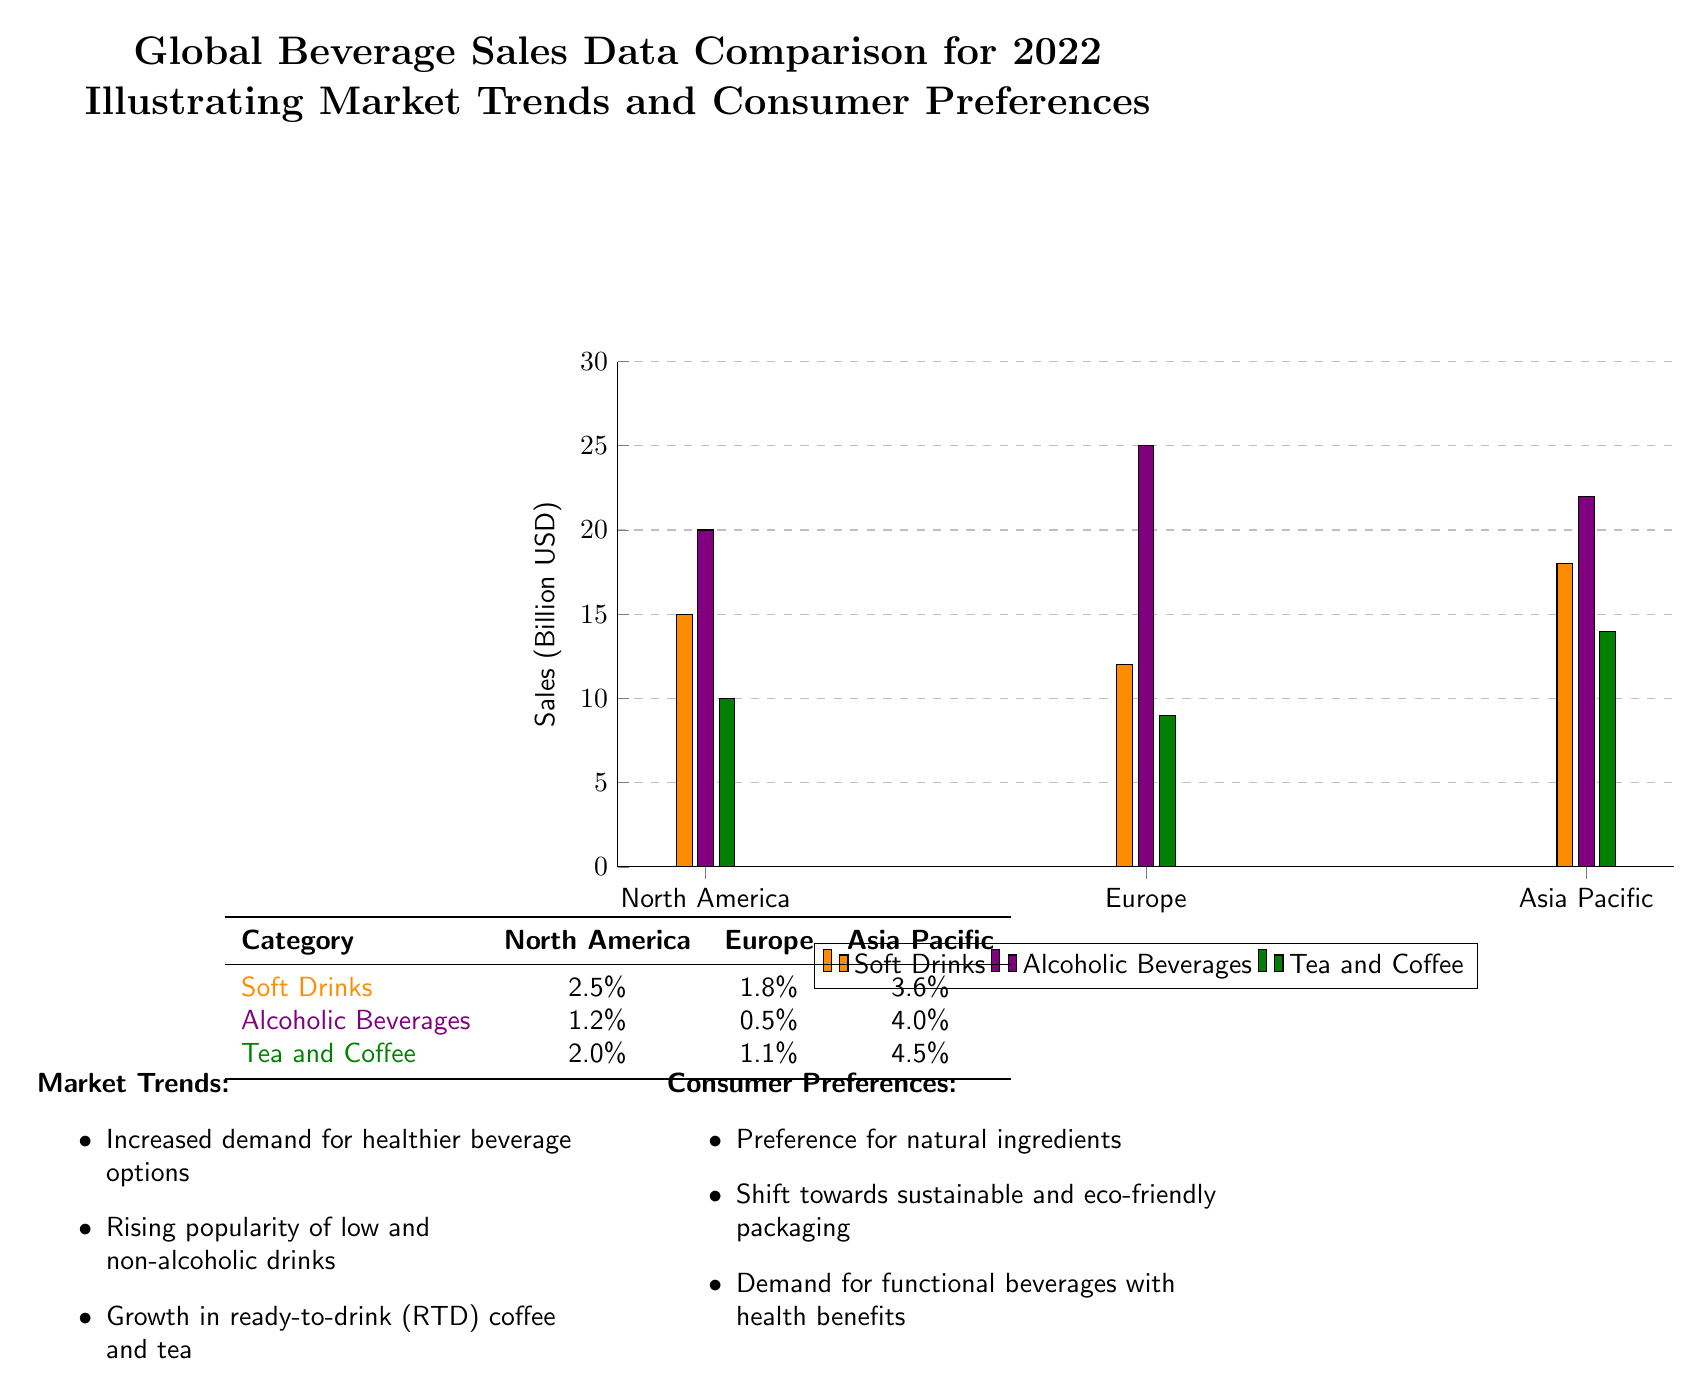What are the total sales in North America for Soft Drinks? The diagram shows the sales for Soft Drinks in North America as 15 billion USD, specifically indicated in the bar chart.
Answer: 15 billion USD What is the sales value of Alcoholic Beverages in Asia Pacific? The diagram presents a bar for Alcoholic Beverages in Asia Pacific, with a sales figure marked at 22 billion USD.
Answer: 22 billion USD Which category has the highest growth rate in Asia Pacific? In the growth rates table, the highest growth percentage in Asia Pacific is noted for Tea and Coffee, with a rate of 4.5%.
Answer: 4.5% What percentage growth did Alcoholic Beverages experience in Europe? The figure for the growth rate of Alcoholic Beverages in Europe is listed as 0.5%, as shown in the growth rates table.
Answer: 0.5% Which region has the highest sales for Soft Drinks? Looking at the bar chart, Asia Pacific shows the highest sales for Soft Drinks at 18 billion USD, more than North America and Europe.
Answer: Asia Pacific What are two consumer preferences highlighted in the diagram? The diagram identifies two consumer preferences as "Preference for natural ingredients" and "Shift towards sustainable and eco-friendly packaging," which are presented in the Consumer Preferences section.
Answer: Preference for natural ingredients, Shift towards sustainable and eco-friendly packaging How many beverage categories are represented in the diagram? The diagram features three beverage categories: Soft Drinks, Alcoholic Beverages, and Tea and Coffee, as listed in the legend.
Answer: Three What is the total sales for Alcoholic Beverages in North America and Europe combined? Adding the sales figures for Alcoholic Beverages, North America (20 billion USD) and Europe (25 billion USD), results in a total of 45 billion USD.
Answer: 45 billion USD What trend is noted regarding ready-to-drink beverages? The diagram mentions "Growth in ready-to-drink (RTD) coffee and tea" as a market trend, indicating increased consumer interest in this segment.
Answer: Growth in ready-to-drink coffee and tea 